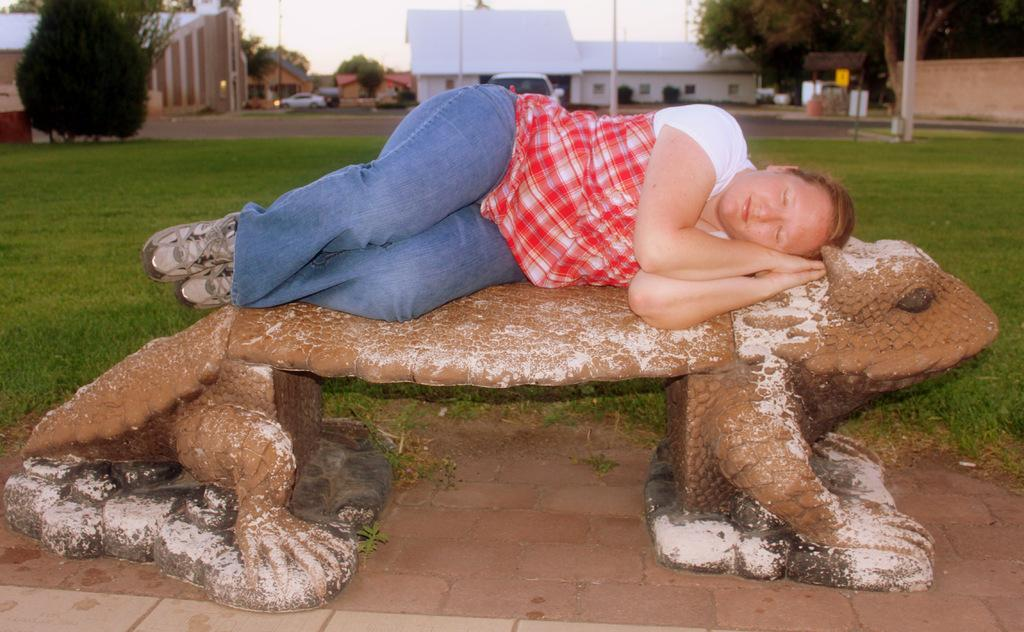What is the woman doing in the image? The woman is lying on a platform in the image. What type of natural environment is visible in the image? Grass, trees, and the sky are visible in the image. What type of man-made structures can be seen in the image? Buildings and poles are present in the image. What else is present in the image besides the woman and the natural environment? Vehicles are present in the image. How does the woman wash her clothes in the image? There is no indication in the image that the woman is washing clothes, and no washing facilities are visible. 